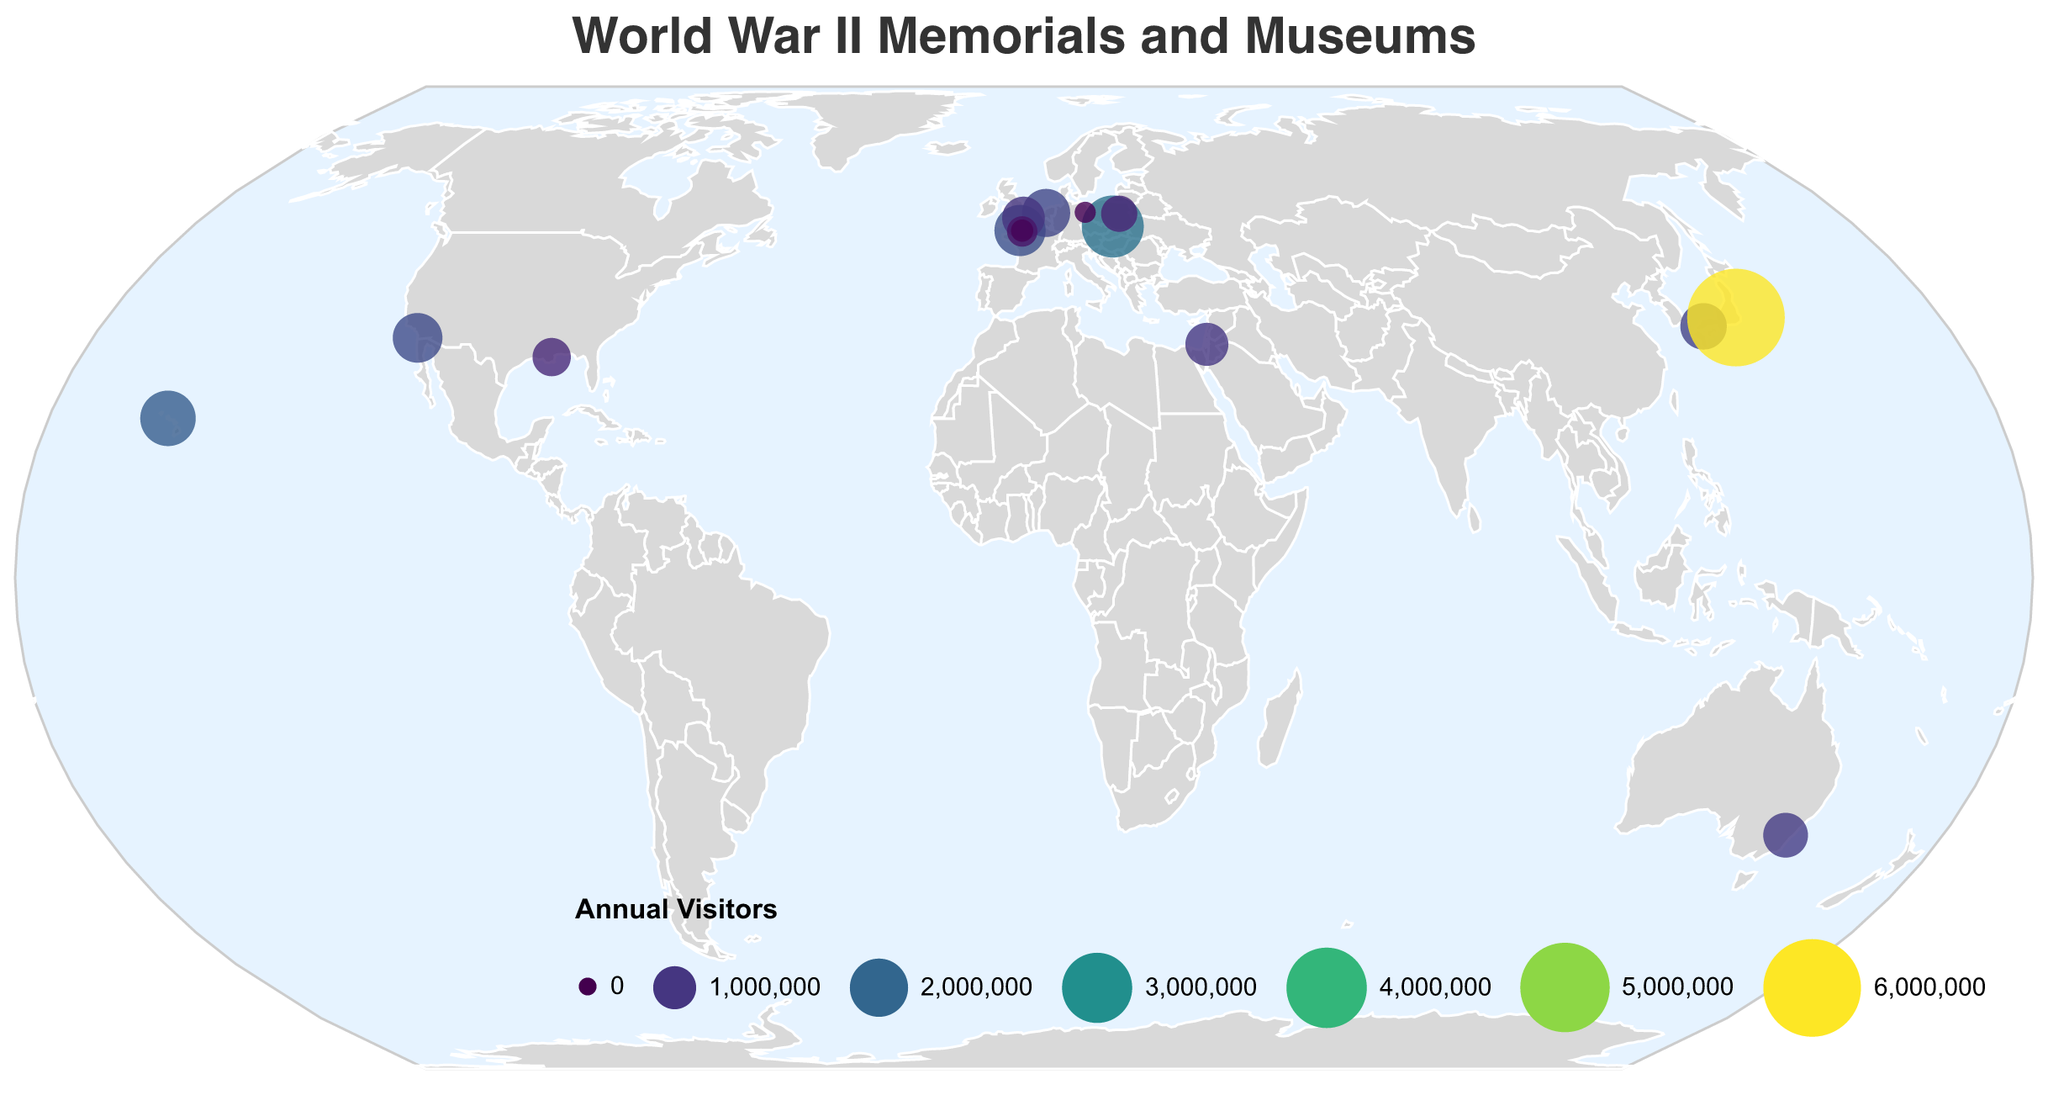What is the name of the museum with the highest number of annual visitors? The plot shows various World War II memorials and museums with differently sized and colored markers indicating visitor numbers. The largest marker corresponds to 6,000,000 annual visitors, located at Yasukuni Shrine.
Answer: Yasukuni Shrine Which museum has more annual visitors, Auschwitz-Birkenau Memorial or the Normandy American Cemetery? Locate both markers on the plot and compare their sizes and shades. Auschwitz-Birkenau Memorial has a larger marker indicating 2,300,000 visitors, while the Normandy American Cemetery has 1,500,000.
Answer: Auschwitz-Birkenau Memorial What is the total number of annual visitors for the memorials and museums located in the United States? Identify the U.S. locations: Pearl Harbor National Memorial (1,800,000), National WWII Museum (750,000), USS Midway Museum (1,400,000). Sum their visitors: 1,800,000 + 750,000 + 1,400,000 = 3,950,000.
Answer: 3,950,000 Which museum in Europe has the lowest number of annual visitors? From the European locations, identify the smallest marker. The German-Russian Museum in Berlin has the smallest with 85,000 visitors.
Answer: German-Russian Museum How does the annual visitation of the Hiroshima Peace Memorial compare to the Anne Frank House? Locate both markers and check their sizes and colors. Hiroshima Peace Memorial has 1,200,000 visitors, while Anne Frank House has 1,300,000 visitors. The Anne Frank House has slightly more visitors.
Answer: Anne Frank House What is the average number of annual visitors for all the memorials and museums depicted? Sum all visitor numbers: 15,485,000. There are 14 locations. Calculate the average: 15,485,000 / 14 = 1,106,071.43 visitors.
Answer: 1,106,071.43 Which continents have World War II memorials and museums represented on this plot? Identify continents with markers: North America, Europe, Asia, and Australia.
Answer: North America, Europe, Asia, Australia What patterns can be observed in the geographic distribution of World War II memorials and museums with high annual visitor numbers? High visitor numbers are seen in Japan (Yasukuni Shrine), the U.S. (Pearl Harbor, USS Midway), Poland (Auschwitz-Birkenau), and France (Normandy). These locations correlate with significant World War II events and battles, suggesting that sites directly tied to major events draw more visitors.
Answer: Sites tied to major events attract high visitors What is the most visited memorial in Asia? From the plot, identify the markers in Asia and compare their sizes. Yasukuni Shrine in Japan, with 6,000,000 visitors, is the most visited.
Answer: Yasukuni Shrine 